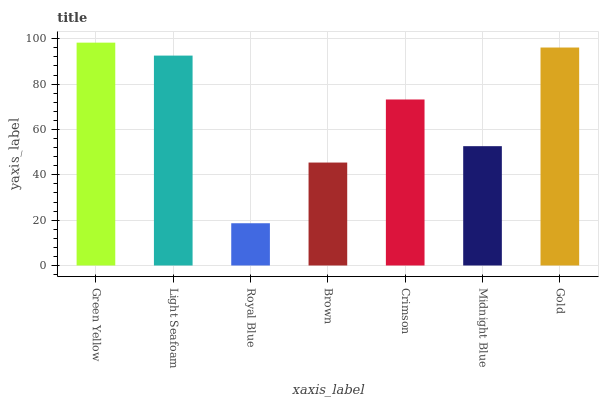Is Royal Blue the minimum?
Answer yes or no. Yes. Is Green Yellow the maximum?
Answer yes or no. Yes. Is Light Seafoam the minimum?
Answer yes or no. No. Is Light Seafoam the maximum?
Answer yes or no. No. Is Green Yellow greater than Light Seafoam?
Answer yes or no. Yes. Is Light Seafoam less than Green Yellow?
Answer yes or no. Yes. Is Light Seafoam greater than Green Yellow?
Answer yes or no. No. Is Green Yellow less than Light Seafoam?
Answer yes or no. No. Is Crimson the high median?
Answer yes or no. Yes. Is Crimson the low median?
Answer yes or no. Yes. Is Gold the high median?
Answer yes or no. No. Is Green Yellow the low median?
Answer yes or no. No. 